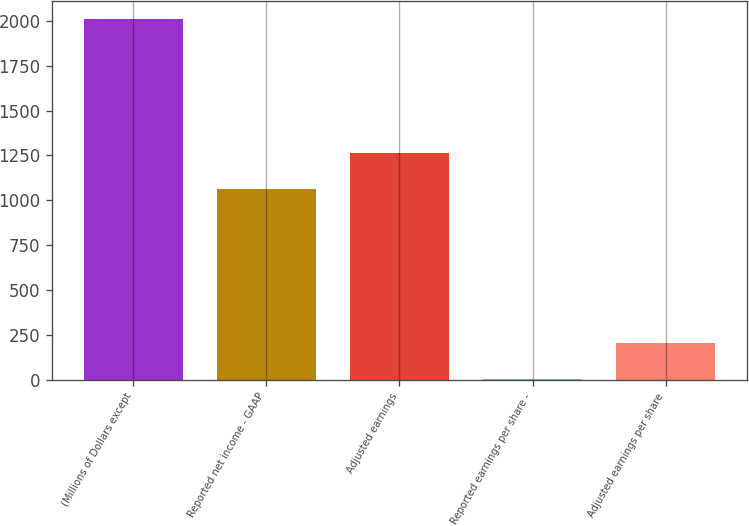<chart> <loc_0><loc_0><loc_500><loc_500><bar_chart><fcel>(Millions of Dollars except<fcel>Reported net income - GAAP<fcel>Adjusted earnings<fcel>Reported earnings per share -<fcel>Adjusted earnings per share<nl><fcel>2013<fcel>1062<fcel>1262.94<fcel>3.62<fcel>204.56<nl></chart> 